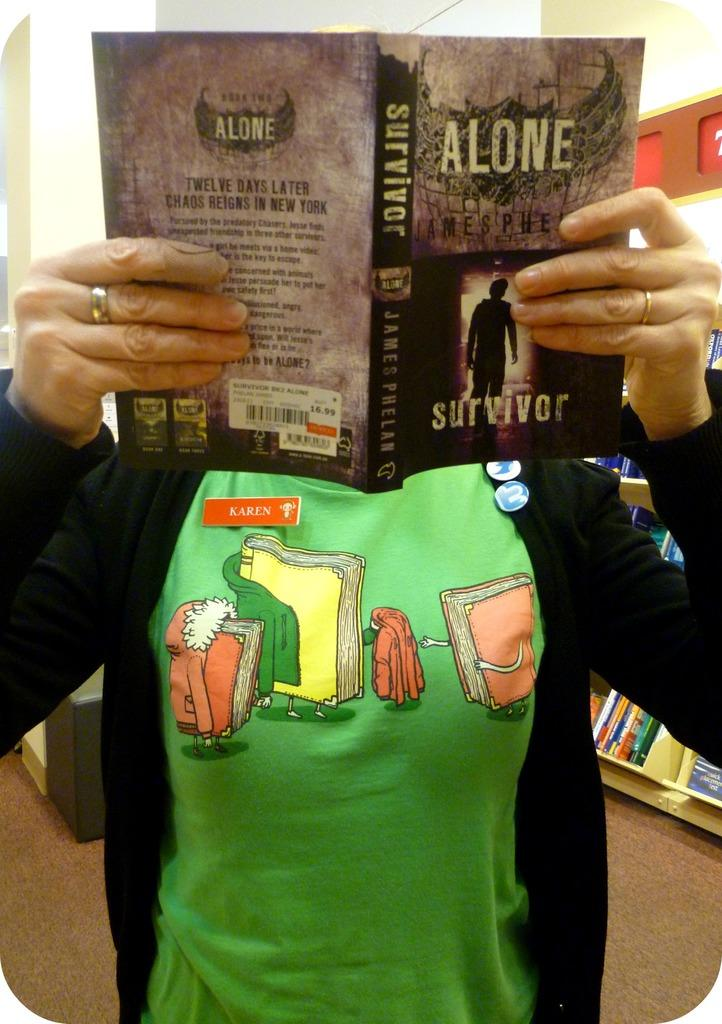<image>
Describe the image concisely. Somebody with a green shirt holding a book titled "Alone". 